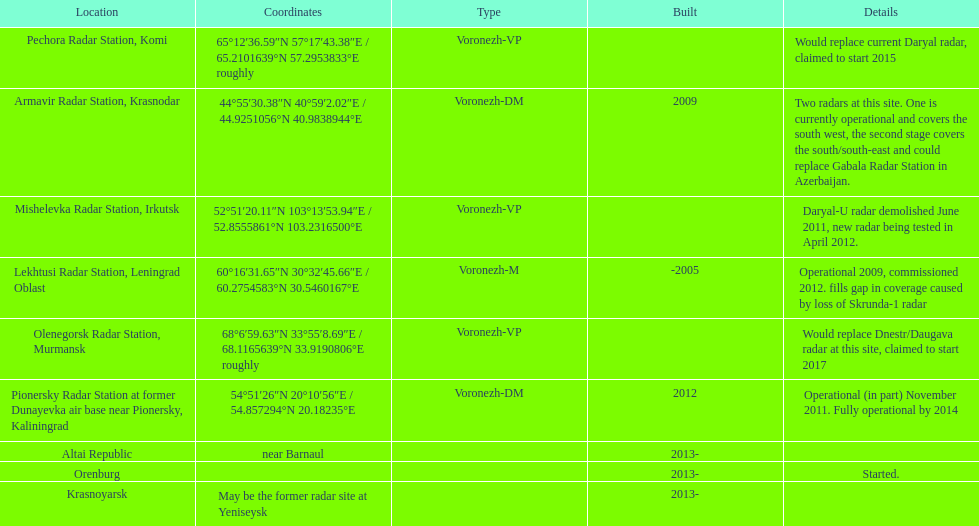How many voronezh radars are in kaliningrad or in krasnodar? 2. Can you give me this table as a dict? {'header': ['Location', 'Coordinates', 'Type', 'Built', 'Details'], 'rows': [['Pechora Radar Station, Komi', '65°12′36.59″N 57°17′43.38″E\ufeff / \ufeff65.2101639°N 57.2953833°E roughly', 'Voronezh-VP', '', 'Would replace current Daryal radar, claimed to start 2015'], ['Armavir Radar Station, Krasnodar', '44°55′30.38″N 40°59′2.02″E\ufeff / \ufeff44.9251056°N 40.9838944°E', 'Voronezh-DM', '2009', 'Two radars at this site. One is currently operational and covers the south west, the second stage covers the south/south-east and could replace Gabala Radar Station in Azerbaijan.'], ['Mishelevka Radar Station, Irkutsk', '52°51′20.11″N 103°13′53.94″E\ufeff / \ufeff52.8555861°N 103.2316500°E', 'Voronezh-VP', '', 'Daryal-U radar demolished June 2011, new radar being tested in April 2012.'], ['Lekhtusi Radar Station, Leningrad Oblast', '60°16′31.65″N 30°32′45.66″E\ufeff / \ufeff60.2754583°N 30.5460167°E', 'Voronezh-M', '-2005', 'Operational 2009, commissioned 2012. fills gap in coverage caused by loss of Skrunda-1 radar'], ['Olenegorsk Radar Station, Murmansk', '68°6′59.63″N 33°55′8.69″E\ufeff / \ufeff68.1165639°N 33.9190806°E roughly', 'Voronezh-VP', '', 'Would replace Dnestr/Daugava radar at this site, claimed to start 2017'], ['Pionersky Radar Station at former Dunayevka air base near Pionersky, Kaliningrad', '54°51′26″N 20°10′56″E\ufeff / \ufeff54.857294°N 20.18235°E', 'Voronezh-DM', '2012', 'Operational (in part) November 2011. Fully operational by 2014'], ['Altai Republic', 'near Barnaul', '', '2013-', ''], ['Orenburg', '', '', '2013-', 'Started.'], ['Krasnoyarsk', 'May be the former radar site at Yeniseysk', '', '2013-', '']]} 